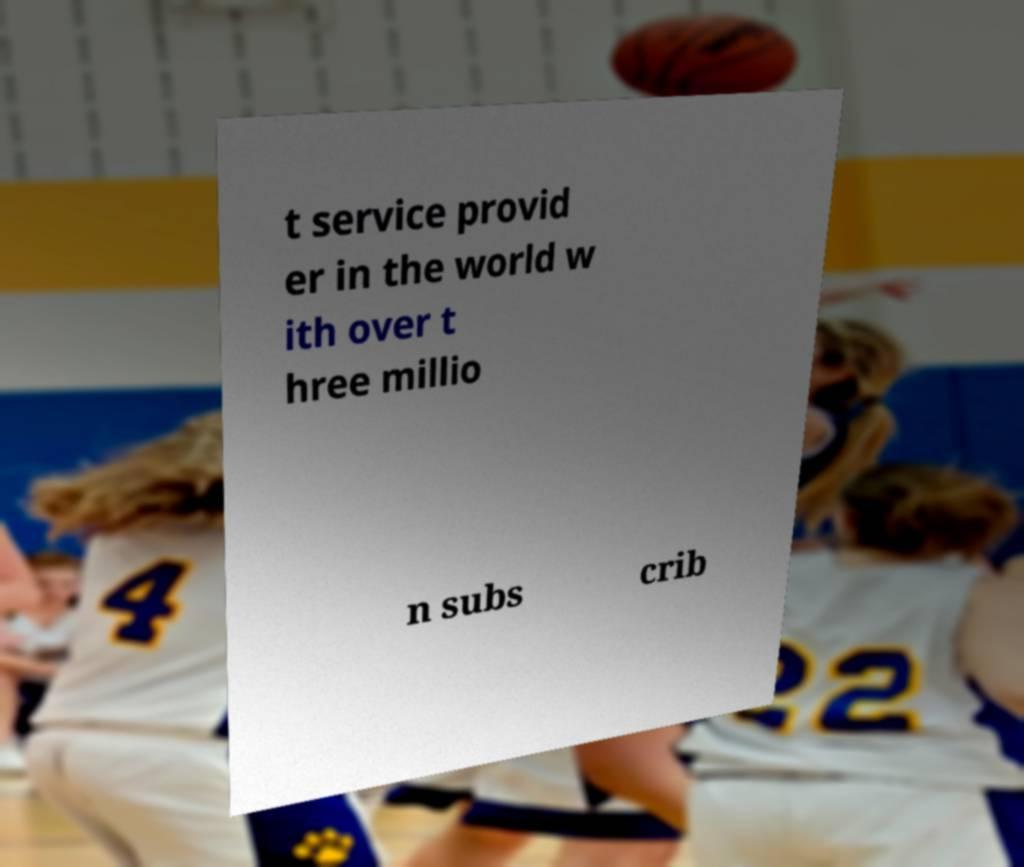Could you extract and type out the text from this image? t service provid er in the world w ith over t hree millio n subs crib 